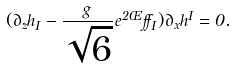<formula> <loc_0><loc_0><loc_500><loc_500>( \partial _ { z } h _ { I } - \frac { g } { \sqrt { 6 } } e ^ { 2 \phi } \alpha _ { I } ) \partial _ { x } h ^ { I } = 0 .</formula> 